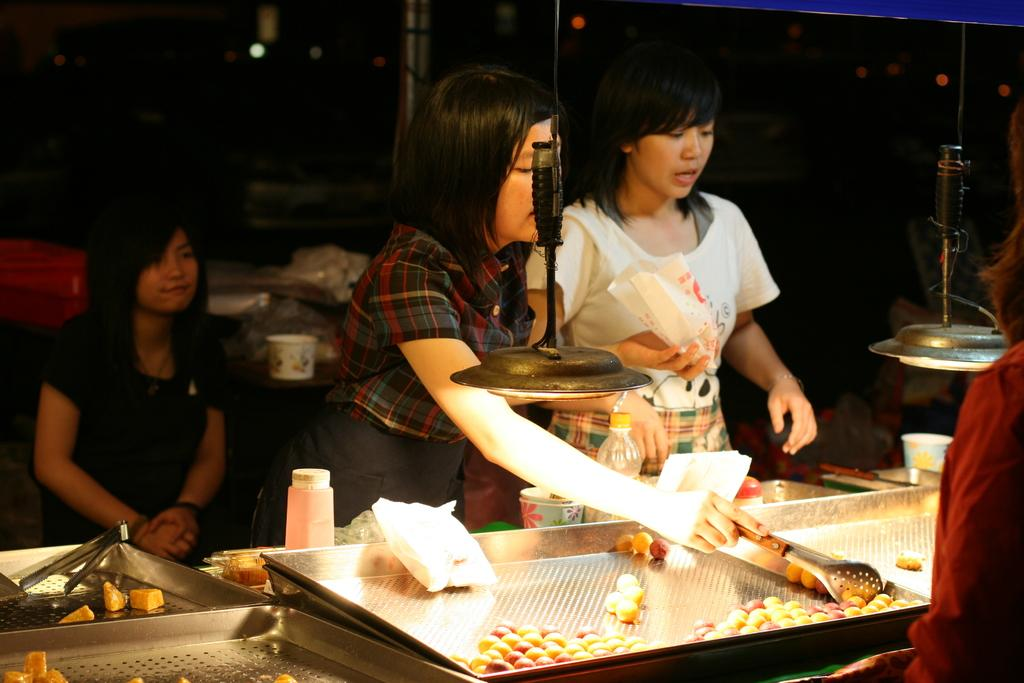How many people are in the image? There are three women in the image. What are two of the women doing in the image? Two of the women are standing in front of a desk. What can be observed about the background of the image? The background of the image is completely dark. Is there any toothpaste visible on the desk in the image? There is no toothpaste present in the image. What type of weather is depicted in the image? The image does not depict any weather conditions, as the background is completely dark. 